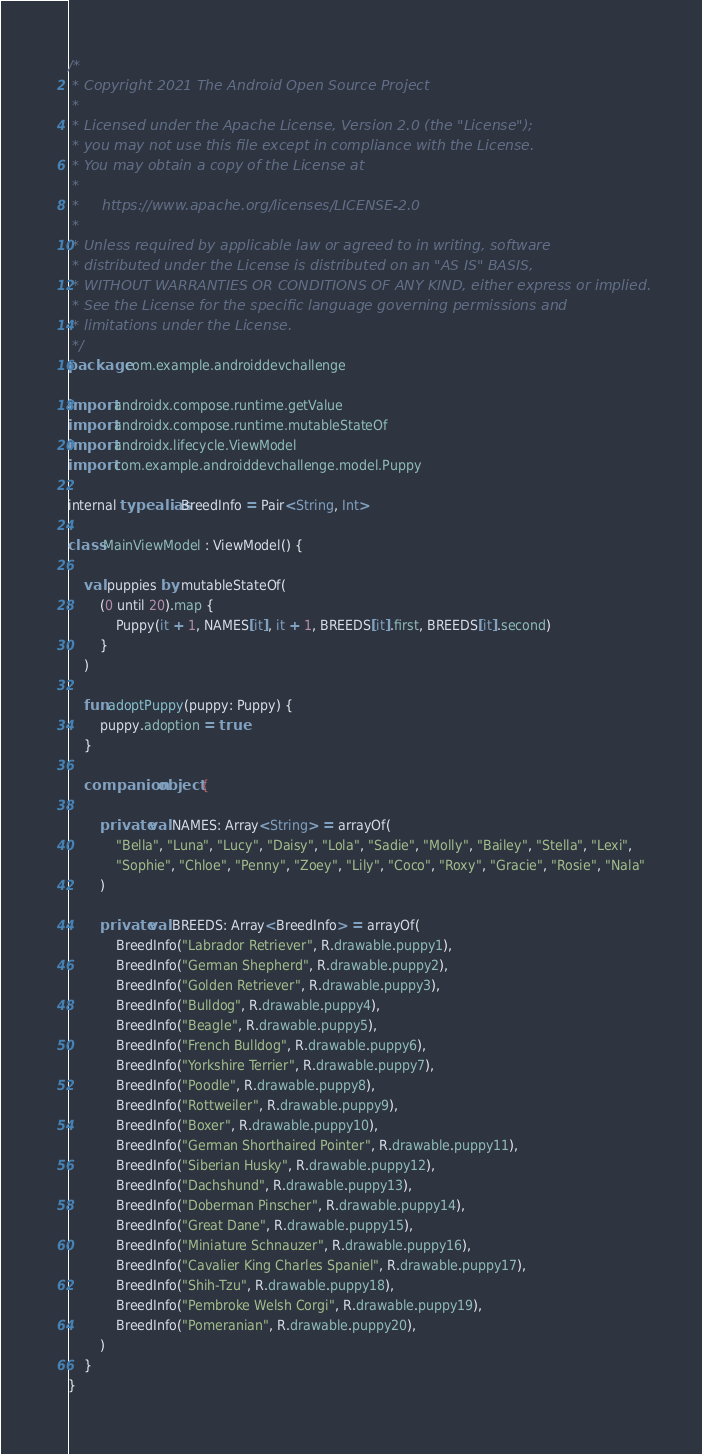<code> <loc_0><loc_0><loc_500><loc_500><_Kotlin_>/*
 * Copyright 2021 The Android Open Source Project
 *
 * Licensed under the Apache License, Version 2.0 (the "License");
 * you may not use this file except in compliance with the License.
 * You may obtain a copy of the License at
 *
 *     https://www.apache.org/licenses/LICENSE-2.0
 *
 * Unless required by applicable law or agreed to in writing, software
 * distributed under the License is distributed on an "AS IS" BASIS,
 * WITHOUT WARRANTIES OR CONDITIONS OF ANY KIND, either express or implied.
 * See the License for the specific language governing permissions and
 * limitations under the License.
 */
package com.example.androiddevchallenge

import androidx.compose.runtime.getValue
import androidx.compose.runtime.mutableStateOf
import androidx.lifecycle.ViewModel
import com.example.androiddevchallenge.model.Puppy

internal typealias BreedInfo = Pair<String, Int>

class MainViewModel : ViewModel() {

    val puppies by mutableStateOf(
        (0 until 20).map {
            Puppy(it + 1, NAMES[it], it + 1, BREEDS[it].first, BREEDS[it].second)
        }
    )

    fun adoptPuppy(puppy: Puppy) {
        puppy.adoption = true
    }

    companion object {

        private val NAMES: Array<String> = arrayOf(
            "Bella", "Luna", "Lucy", "Daisy", "Lola", "Sadie", "Molly", "Bailey", "Stella", "Lexi",
            "Sophie", "Chloe", "Penny", "Zoey", "Lily", "Coco", "Roxy", "Gracie", "Rosie", "Nala"
        )

        private val BREEDS: Array<BreedInfo> = arrayOf(
            BreedInfo("Labrador Retriever", R.drawable.puppy1),
            BreedInfo("German Shepherd", R.drawable.puppy2),
            BreedInfo("Golden Retriever", R.drawable.puppy3),
            BreedInfo("Bulldog", R.drawable.puppy4),
            BreedInfo("Beagle", R.drawable.puppy5),
            BreedInfo("French Bulldog", R.drawable.puppy6),
            BreedInfo("Yorkshire Terrier", R.drawable.puppy7),
            BreedInfo("Poodle", R.drawable.puppy8),
            BreedInfo("Rottweiler", R.drawable.puppy9),
            BreedInfo("Boxer", R.drawable.puppy10),
            BreedInfo("German Shorthaired Pointer", R.drawable.puppy11),
            BreedInfo("Siberian Husky", R.drawable.puppy12),
            BreedInfo("Dachshund", R.drawable.puppy13),
            BreedInfo("Doberman Pinscher", R.drawable.puppy14),
            BreedInfo("Great Dane", R.drawable.puppy15),
            BreedInfo("Miniature Schnauzer", R.drawable.puppy16),
            BreedInfo("Cavalier King Charles Spaniel", R.drawable.puppy17),
            BreedInfo("Shih-Tzu", R.drawable.puppy18),
            BreedInfo("Pembroke Welsh Corgi", R.drawable.puppy19),
            BreedInfo("Pomeranian", R.drawable.puppy20),
        )
    }
}
</code> 